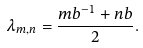Convert formula to latex. <formula><loc_0><loc_0><loc_500><loc_500>\lambda _ { m , n } = \frac { m b ^ { - 1 } + n b } 2 .</formula> 